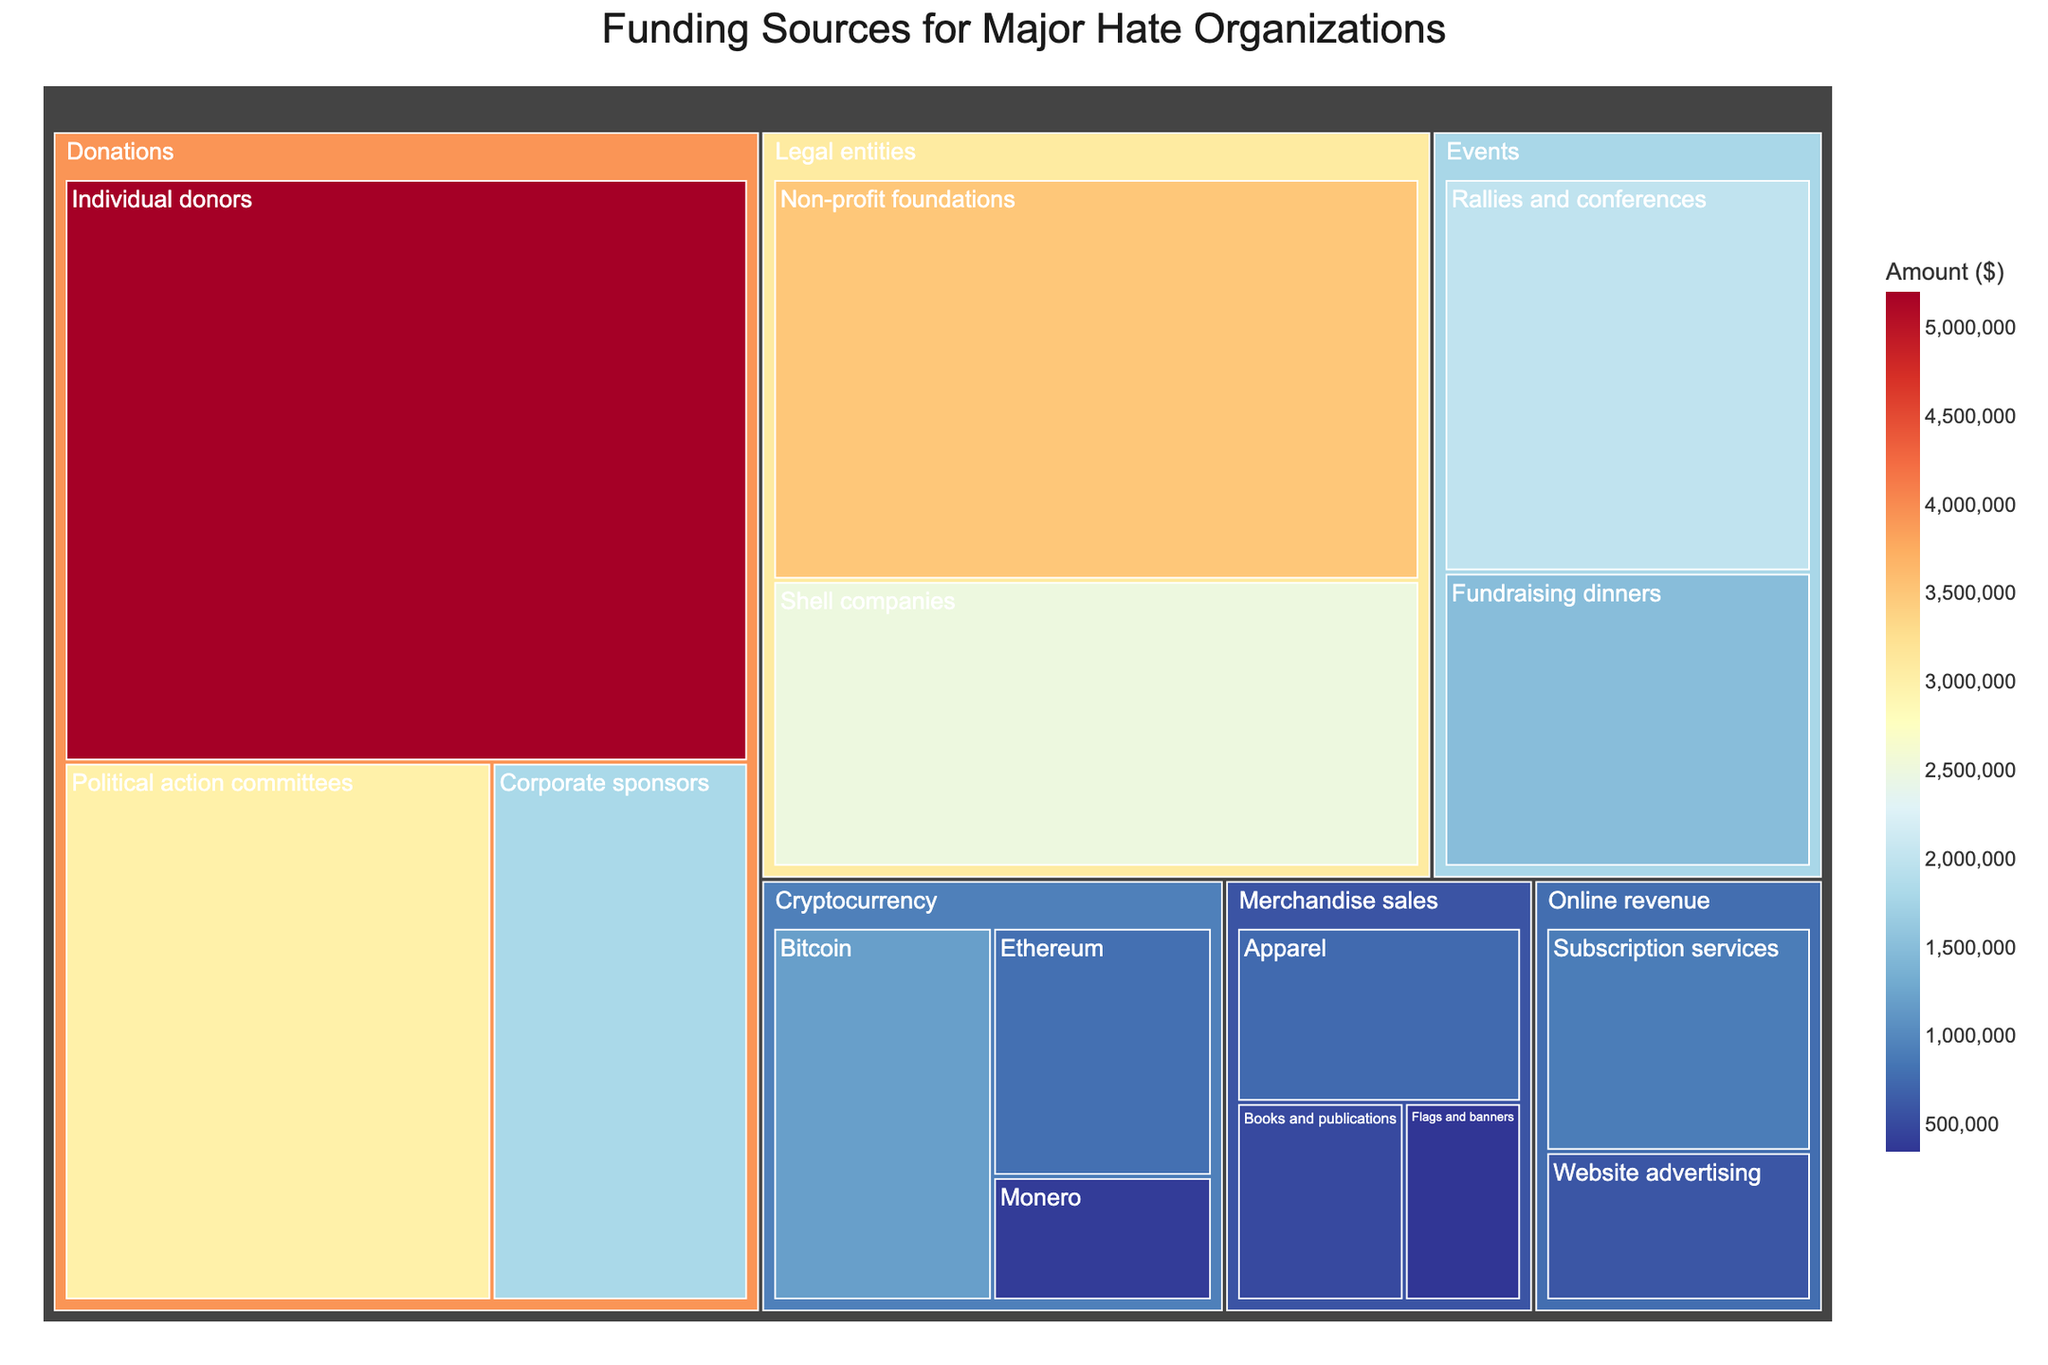What is the largest funding source category? To determine the largest category, sum the values of each category and compare. We see that Donations have subcategories with values (5200000 + 1800000 + 3000000) = 10000000, Merchandise sales have (750000 + 500000 + 350000) = 1600000, Cryptocurrency has (1200000 + 800000 + 400000) = 2400000, Events have (2000000 + 1500000) = 3500000, Online revenue has (600000 + 900000) = 1500000, and Legal entities have (2500000 + 3500000) = 6000000. The highest total is Donations, with 10,000,000.
Answer: Donations Which subcategory within Donations contributes the most? To find the largest subcategory within Donations, compare the values of its subcategories: Individual donors (5200000), Corporate sponsors (1800000), Political action committees (3000000). Individual donors is the highest at 5,200,000.
Answer: Individual donors How much money is raised from Cryptocurrency in total? Sum up all the values in the Cryptocurrency category: Bitcoin (1200000), Ethereum (800000), and Monero (400000). The total is 1200000 + 800000 + 400000 = 2400000.
Answer: 2,400,000 Which subcategory has the smallest value? Compare the values across all subcategories. The smallest values are Flags and banners (350000).
Answer: Flags and banners How does the total from Legal entities compare to the total from Events? Calculate the total values: Legal entities (2500000 + 3500000) = 6000000 and Events (2000000 + 1500000) = 3500000. Legal entities total (6000000) is greater than Events total (3500000) by 2500000.
Answer: Legal entities are 2,500,000 higher What is the value difference between Website advertising and Subscription services in Online revenue? Compare the values of Website advertising (600000) and Subscription services (900000). The difference is 900000 - 600000 = 300000.
Answer: 300,000 What is the average amount raised per subcategory in Merchandise sales? Calculate the total for Merchandise sales: Apparel (750000), Books and publications (500000), and Flags and banners (350000), which sums up to 750000 + 500000 + 350000 = 1600000. There are 3 subcategories, so the average is 1600000 / 3 = 533333.33.
Answer: 533,333.33 Which category has higher funding, Cryptocurrency or Online revenue? Sum the values for each category: Cryptocurrency totals to 2400000 and Online revenue totals to (600000 + 900000) = 1500000. Cryptocurrency total (2400000) is higher than Online revenue total (1500000).
Answer: Cryptocurrency What is the combined funding from Events and Legal entities? Calculate the total values: Events (2000000 + 1500000) = 3500000 and Legal entities (2500000 + 3500000) = 6000000. Combining these totals gives 3500000 + 6000000 = 9500000.
Answer: 9,500,000 